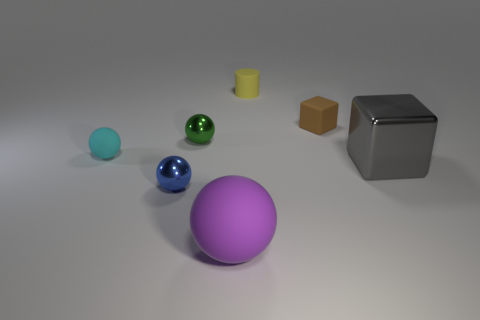What is the big gray block made of?
Give a very brief answer. Metal. What size is the blue metal object that is the same shape as the small cyan object?
Offer a terse response. Small. How big is the metallic sphere in front of the metallic cube?
Keep it short and to the point. Small. There is a purple rubber thing; are there any cylinders left of it?
Give a very brief answer. No. Does the small brown object have the same shape as the small thing to the left of the blue sphere?
Your answer should be very brief. No. What is the color of the other ball that is the same material as the large purple ball?
Ensure brevity in your answer.  Cyan. The large matte object has what color?
Make the answer very short. Purple. Do the big gray thing and the purple thing that is in front of the yellow matte thing have the same material?
Make the answer very short. No. What number of objects are on the right side of the small green thing and behind the purple thing?
Provide a succinct answer. 3. There is a gray shiny object that is the same size as the purple thing; what shape is it?
Make the answer very short. Cube. 